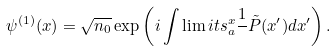Convert formula to latex. <formula><loc_0><loc_0><loc_500><loc_500>\psi ^ { ( 1 ) } ( x ) = \sqrt { n _ { 0 } } \exp \left ( i \int \lim i t s _ { a } ^ { x } \frac { 1 } { } { \tilde { P } } ( x ^ { \prime } ) d x ^ { \prime } \right ) .</formula> 